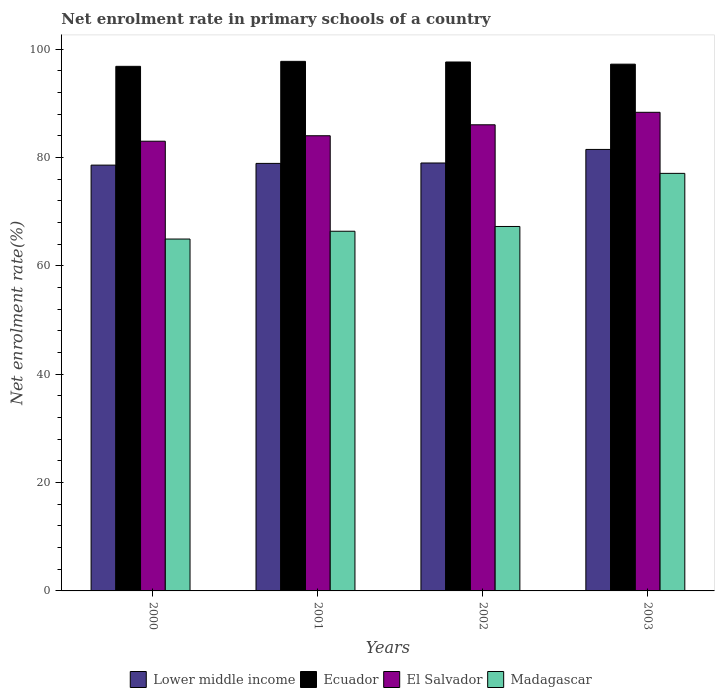How many groups of bars are there?
Your answer should be very brief. 4. Are the number of bars on each tick of the X-axis equal?
Ensure brevity in your answer.  Yes. How many bars are there on the 2nd tick from the left?
Offer a terse response. 4. How many bars are there on the 4th tick from the right?
Ensure brevity in your answer.  4. What is the label of the 1st group of bars from the left?
Offer a very short reply. 2000. What is the net enrolment rate in primary schools in El Salvador in 2003?
Offer a terse response. 88.34. Across all years, what is the maximum net enrolment rate in primary schools in El Salvador?
Keep it short and to the point. 88.34. Across all years, what is the minimum net enrolment rate in primary schools in El Salvador?
Provide a succinct answer. 83.01. What is the total net enrolment rate in primary schools in El Salvador in the graph?
Offer a terse response. 341.4. What is the difference between the net enrolment rate in primary schools in Lower middle income in 2000 and that in 2002?
Make the answer very short. -0.39. What is the difference between the net enrolment rate in primary schools in El Salvador in 2001 and the net enrolment rate in primary schools in Ecuador in 2002?
Give a very brief answer. -13.61. What is the average net enrolment rate in primary schools in Madagascar per year?
Provide a succinct answer. 68.92. In the year 2000, what is the difference between the net enrolment rate in primary schools in Lower middle income and net enrolment rate in primary schools in Ecuador?
Offer a very short reply. -18.23. In how many years, is the net enrolment rate in primary schools in Ecuador greater than 68 %?
Provide a succinct answer. 4. What is the ratio of the net enrolment rate in primary schools in Madagascar in 2000 to that in 2002?
Your answer should be compact. 0.97. Is the net enrolment rate in primary schools in Lower middle income in 2000 less than that in 2003?
Make the answer very short. Yes. What is the difference between the highest and the second highest net enrolment rate in primary schools in Madagascar?
Make the answer very short. 9.8. What is the difference between the highest and the lowest net enrolment rate in primary schools in El Salvador?
Ensure brevity in your answer.  5.34. Is the sum of the net enrolment rate in primary schools in Madagascar in 2002 and 2003 greater than the maximum net enrolment rate in primary schools in Lower middle income across all years?
Your answer should be compact. Yes. What does the 1st bar from the left in 2002 represents?
Offer a terse response. Lower middle income. What does the 2nd bar from the right in 2003 represents?
Your answer should be very brief. El Salvador. Is it the case that in every year, the sum of the net enrolment rate in primary schools in El Salvador and net enrolment rate in primary schools in Lower middle income is greater than the net enrolment rate in primary schools in Ecuador?
Your answer should be compact. Yes. How many bars are there?
Ensure brevity in your answer.  16. Are all the bars in the graph horizontal?
Provide a short and direct response. No. How many years are there in the graph?
Ensure brevity in your answer.  4. Are the values on the major ticks of Y-axis written in scientific E-notation?
Offer a terse response. No. Does the graph contain any zero values?
Provide a succinct answer. No. Does the graph contain grids?
Offer a very short reply. No. Where does the legend appear in the graph?
Give a very brief answer. Bottom center. How are the legend labels stacked?
Provide a succinct answer. Horizontal. What is the title of the graph?
Keep it short and to the point. Net enrolment rate in primary schools of a country. What is the label or title of the X-axis?
Make the answer very short. Years. What is the label or title of the Y-axis?
Your answer should be compact. Net enrolment rate(%). What is the Net enrolment rate(%) in Lower middle income in 2000?
Provide a short and direct response. 78.59. What is the Net enrolment rate(%) in Ecuador in 2000?
Make the answer very short. 96.83. What is the Net enrolment rate(%) in El Salvador in 2000?
Make the answer very short. 83.01. What is the Net enrolment rate(%) in Madagascar in 2000?
Ensure brevity in your answer.  64.95. What is the Net enrolment rate(%) in Lower middle income in 2001?
Keep it short and to the point. 78.91. What is the Net enrolment rate(%) of Ecuador in 2001?
Your answer should be very brief. 97.75. What is the Net enrolment rate(%) of El Salvador in 2001?
Keep it short and to the point. 84.02. What is the Net enrolment rate(%) in Madagascar in 2001?
Offer a terse response. 66.39. What is the Net enrolment rate(%) in Lower middle income in 2002?
Make the answer very short. 78.99. What is the Net enrolment rate(%) of Ecuador in 2002?
Offer a terse response. 97.63. What is the Net enrolment rate(%) in El Salvador in 2002?
Your answer should be very brief. 86.04. What is the Net enrolment rate(%) in Madagascar in 2002?
Offer a very short reply. 67.27. What is the Net enrolment rate(%) of Lower middle income in 2003?
Your answer should be compact. 81.49. What is the Net enrolment rate(%) in Ecuador in 2003?
Make the answer very short. 97.23. What is the Net enrolment rate(%) of El Salvador in 2003?
Your answer should be very brief. 88.34. What is the Net enrolment rate(%) of Madagascar in 2003?
Provide a succinct answer. 77.07. Across all years, what is the maximum Net enrolment rate(%) in Lower middle income?
Give a very brief answer. 81.49. Across all years, what is the maximum Net enrolment rate(%) in Ecuador?
Your answer should be compact. 97.75. Across all years, what is the maximum Net enrolment rate(%) of El Salvador?
Offer a terse response. 88.34. Across all years, what is the maximum Net enrolment rate(%) in Madagascar?
Your answer should be compact. 77.07. Across all years, what is the minimum Net enrolment rate(%) of Lower middle income?
Ensure brevity in your answer.  78.59. Across all years, what is the minimum Net enrolment rate(%) of Ecuador?
Provide a short and direct response. 96.83. Across all years, what is the minimum Net enrolment rate(%) in El Salvador?
Provide a short and direct response. 83.01. Across all years, what is the minimum Net enrolment rate(%) in Madagascar?
Your answer should be very brief. 64.95. What is the total Net enrolment rate(%) in Lower middle income in the graph?
Give a very brief answer. 317.98. What is the total Net enrolment rate(%) of Ecuador in the graph?
Keep it short and to the point. 389.43. What is the total Net enrolment rate(%) of El Salvador in the graph?
Give a very brief answer. 341.4. What is the total Net enrolment rate(%) of Madagascar in the graph?
Make the answer very short. 275.68. What is the difference between the Net enrolment rate(%) in Lower middle income in 2000 and that in 2001?
Keep it short and to the point. -0.32. What is the difference between the Net enrolment rate(%) of Ecuador in 2000 and that in 2001?
Your answer should be very brief. -0.92. What is the difference between the Net enrolment rate(%) in El Salvador in 2000 and that in 2001?
Give a very brief answer. -1.01. What is the difference between the Net enrolment rate(%) of Madagascar in 2000 and that in 2001?
Your answer should be very brief. -1.44. What is the difference between the Net enrolment rate(%) in Lower middle income in 2000 and that in 2002?
Provide a succinct answer. -0.39. What is the difference between the Net enrolment rate(%) in Ecuador in 2000 and that in 2002?
Keep it short and to the point. -0.8. What is the difference between the Net enrolment rate(%) of El Salvador in 2000 and that in 2002?
Offer a very short reply. -3.03. What is the difference between the Net enrolment rate(%) of Madagascar in 2000 and that in 2002?
Offer a very short reply. -2.32. What is the difference between the Net enrolment rate(%) in Lower middle income in 2000 and that in 2003?
Your response must be concise. -2.9. What is the difference between the Net enrolment rate(%) in Ecuador in 2000 and that in 2003?
Provide a short and direct response. -0.4. What is the difference between the Net enrolment rate(%) in El Salvador in 2000 and that in 2003?
Give a very brief answer. -5.34. What is the difference between the Net enrolment rate(%) in Madagascar in 2000 and that in 2003?
Provide a succinct answer. -12.12. What is the difference between the Net enrolment rate(%) in Lower middle income in 2001 and that in 2002?
Your answer should be very brief. -0.08. What is the difference between the Net enrolment rate(%) of Ecuador in 2001 and that in 2002?
Keep it short and to the point. 0.12. What is the difference between the Net enrolment rate(%) in El Salvador in 2001 and that in 2002?
Ensure brevity in your answer.  -2.02. What is the difference between the Net enrolment rate(%) of Madagascar in 2001 and that in 2002?
Offer a terse response. -0.88. What is the difference between the Net enrolment rate(%) of Lower middle income in 2001 and that in 2003?
Your answer should be very brief. -2.58. What is the difference between the Net enrolment rate(%) in Ecuador in 2001 and that in 2003?
Offer a terse response. 0.52. What is the difference between the Net enrolment rate(%) in El Salvador in 2001 and that in 2003?
Your answer should be compact. -4.33. What is the difference between the Net enrolment rate(%) of Madagascar in 2001 and that in 2003?
Your answer should be compact. -10.68. What is the difference between the Net enrolment rate(%) in Lower middle income in 2002 and that in 2003?
Your answer should be compact. -2.5. What is the difference between the Net enrolment rate(%) of Ecuador in 2002 and that in 2003?
Provide a short and direct response. 0.4. What is the difference between the Net enrolment rate(%) in El Salvador in 2002 and that in 2003?
Your answer should be very brief. -2.31. What is the difference between the Net enrolment rate(%) in Madagascar in 2002 and that in 2003?
Ensure brevity in your answer.  -9.8. What is the difference between the Net enrolment rate(%) of Lower middle income in 2000 and the Net enrolment rate(%) of Ecuador in 2001?
Give a very brief answer. -19.15. What is the difference between the Net enrolment rate(%) in Lower middle income in 2000 and the Net enrolment rate(%) in El Salvador in 2001?
Your answer should be compact. -5.42. What is the difference between the Net enrolment rate(%) of Lower middle income in 2000 and the Net enrolment rate(%) of Madagascar in 2001?
Ensure brevity in your answer.  12.21. What is the difference between the Net enrolment rate(%) of Ecuador in 2000 and the Net enrolment rate(%) of El Salvador in 2001?
Keep it short and to the point. 12.81. What is the difference between the Net enrolment rate(%) in Ecuador in 2000 and the Net enrolment rate(%) in Madagascar in 2001?
Keep it short and to the point. 30.44. What is the difference between the Net enrolment rate(%) in El Salvador in 2000 and the Net enrolment rate(%) in Madagascar in 2001?
Make the answer very short. 16.62. What is the difference between the Net enrolment rate(%) of Lower middle income in 2000 and the Net enrolment rate(%) of Ecuador in 2002?
Make the answer very short. -19.03. What is the difference between the Net enrolment rate(%) of Lower middle income in 2000 and the Net enrolment rate(%) of El Salvador in 2002?
Provide a succinct answer. -7.44. What is the difference between the Net enrolment rate(%) in Lower middle income in 2000 and the Net enrolment rate(%) in Madagascar in 2002?
Your answer should be very brief. 11.33. What is the difference between the Net enrolment rate(%) of Ecuador in 2000 and the Net enrolment rate(%) of El Salvador in 2002?
Provide a succinct answer. 10.79. What is the difference between the Net enrolment rate(%) of Ecuador in 2000 and the Net enrolment rate(%) of Madagascar in 2002?
Give a very brief answer. 29.56. What is the difference between the Net enrolment rate(%) of El Salvador in 2000 and the Net enrolment rate(%) of Madagascar in 2002?
Your answer should be compact. 15.74. What is the difference between the Net enrolment rate(%) in Lower middle income in 2000 and the Net enrolment rate(%) in Ecuador in 2003?
Give a very brief answer. -18.63. What is the difference between the Net enrolment rate(%) of Lower middle income in 2000 and the Net enrolment rate(%) of El Salvador in 2003?
Ensure brevity in your answer.  -9.75. What is the difference between the Net enrolment rate(%) in Lower middle income in 2000 and the Net enrolment rate(%) in Madagascar in 2003?
Provide a succinct answer. 1.52. What is the difference between the Net enrolment rate(%) in Ecuador in 2000 and the Net enrolment rate(%) in El Salvador in 2003?
Provide a short and direct response. 8.48. What is the difference between the Net enrolment rate(%) in Ecuador in 2000 and the Net enrolment rate(%) in Madagascar in 2003?
Ensure brevity in your answer.  19.76. What is the difference between the Net enrolment rate(%) in El Salvador in 2000 and the Net enrolment rate(%) in Madagascar in 2003?
Your response must be concise. 5.93. What is the difference between the Net enrolment rate(%) of Lower middle income in 2001 and the Net enrolment rate(%) of Ecuador in 2002?
Ensure brevity in your answer.  -18.72. What is the difference between the Net enrolment rate(%) in Lower middle income in 2001 and the Net enrolment rate(%) in El Salvador in 2002?
Keep it short and to the point. -7.13. What is the difference between the Net enrolment rate(%) in Lower middle income in 2001 and the Net enrolment rate(%) in Madagascar in 2002?
Make the answer very short. 11.64. What is the difference between the Net enrolment rate(%) in Ecuador in 2001 and the Net enrolment rate(%) in El Salvador in 2002?
Provide a short and direct response. 11.71. What is the difference between the Net enrolment rate(%) of Ecuador in 2001 and the Net enrolment rate(%) of Madagascar in 2002?
Keep it short and to the point. 30.48. What is the difference between the Net enrolment rate(%) in El Salvador in 2001 and the Net enrolment rate(%) in Madagascar in 2002?
Offer a very short reply. 16.75. What is the difference between the Net enrolment rate(%) in Lower middle income in 2001 and the Net enrolment rate(%) in Ecuador in 2003?
Provide a short and direct response. -18.32. What is the difference between the Net enrolment rate(%) of Lower middle income in 2001 and the Net enrolment rate(%) of El Salvador in 2003?
Your answer should be very brief. -9.43. What is the difference between the Net enrolment rate(%) of Lower middle income in 2001 and the Net enrolment rate(%) of Madagascar in 2003?
Offer a terse response. 1.84. What is the difference between the Net enrolment rate(%) of Ecuador in 2001 and the Net enrolment rate(%) of El Salvador in 2003?
Give a very brief answer. 9.4. What is the difference between the Net enrolment rate(%) in Ecuador in 2001 and the Net enrolment rate(%) in Madagascar in 2003?
Ensure brevity in your answer.  20.68. What is the difference between the Net enrolment rate(%) of El Salvador in 2001 and the Net enrolment rate(%) of Madagascar in 2003?
Ensure brevity in your answer.  6.94. What is the difference between the Net enrolment rate(%) of Lower middle income in 2002 and the Net enrolment rate(%) of Ecuador in 2003?
Provide a succinct answer. -18.24. What is the difference between the Net enrolment rate(%) in Lower middle income in 2002 and the Net enrolment rate(%) in El Salvador in 2003?
Ensure brevity in your answer.  -9.36. What is the difference between the Net enrolment rate(%) of Lower middle income in 2002 and the Net enrolment rate(%) of Madagascar in 2003?
Make the answer very short. 1.92. What is the difference between the Net enrolment rate(%) in Ecuador in 2002 and the Net enrolment rate(%) in El Salvador in 2003?
Offer a very short reply. 9.29. What is the difference between the Net enrolment rate(%) in Ecuador in 2002 and the Net enrolment rate(%) in Madagascar in 2003?
Offer a terse response. 20.56. What is the difference between the Net enrolment rate(%) of El Salvador in 2002 and the Net enrolment rate(%) of Madagascar in 2003?
Provide a succinct answer. 8.97. What is the average Net enrolment rate(%) of Lower middle income per year?
Your answer should be compact. 79.5. What is the average Net enrolment rate(%) of Ecuador per year?
Your response must be concise. 97.36. What is the average Net enrolment rate(%) of El Salvador per year?
Offer a very short reply. 85.35. What is the average Net enrolment rate(%) in Madagascar per year?
Provide a succinct answer. 68.92. In the year 2000, what is the difference between the Net enrolment rate(%) in Lower middle income and Net enrolment rate(%) in Ecuador?
Provide a succinct answer. -18.23. In the year 2000, what is the difference between the Net enrolment rate(%) in Lower middle income and Net enrolment rate(%) in El Salvador?
Provide a succinct answer. -4.41. In the year 2000, what is the difference between the Net enrolment rate(%) in Lower middle income and Net enrolment rate(%) in Madagascar?
Provide a succinct answer. 13.64. In the year 2000, what is the difference between the Net enrolment rate(%) in Ecuador and Net enrolment rate(%) in El Salvador?
Your answer should be very brief. 13.82. In the year 2000, what is the difference between the Net enrolment rate(%) in Ecuador and Net enrolment rate(%) in Madagascar?
Provide a short and direct response. 31.88. In the year 2000, what is the difference between the Net enrolment rate(%) of El Salvador and Net enrolment rate(%) of Madagascar?
Your answer should be compact. 18.06. In the year 2001, what is the difference between the Net enrolment rate(%) of Lower middle income and Net enrolment rate(%) of Ecuador?
Make the answer very short. -18.84. In the year 2001, what is the difference between the Net enrolment rate(%) of Lower middle income and Net enrolment rate(%) of El Salvador?
Your response must be concise. -5.11. In the year 2001, what is the difference between the Net enrolment rate(%) of Lower middle income and Net enrolment rate(%) of Madagascar?
Ensure brevity in your answer.  12.52. In the year 2001, what is the difference between the Net enrolment rate(%) of Ecuador and Net enrolment rate(%) of El Salvador?
Your answer should be compact. 13.73. In the year 2001, what is the difference between the Net enrolment rate(%) in Ecuador and Net enrolment rate(%) in Madagascar?
Your answer should be compact. 31.36. In the year 2001, what is the difference between the Net enrolment rate(%) of El Salvador and Net enrolment rate(%) of Madagascar?
Your response must be concise. 17.63. In the year 2002, what is the difference between the Net enrolment rate(%) in Lower middle income and Net enrolment rate(%) in Ecuador?
Provide a short and direct response. -18.64. In the year 2002, what is the difference between the Net enrolment rate(%) of Lower middle income and Net enrolment rate(%) of El Salvador?
Make the answer very short. -7.05. In the year 2002, what is the difference between the Net enrolment rate(%) of Lower middle income and Net enrolment rate(%) of Madagascar?
Keep it short and to the point. 11.72. In the year 2002, what is the difference between the Net enrolment rate(%) in Ecuador and Net enrolment rate(%) in El Salvador?
Your answer should be very brief. 11.59. In the year 2002, what is the difference between the Net enrolment rate(%) in Ecuador and Net enrolment rate(%) in Madagascar?
Provide a succinct answer. 30.36. In the year 2002, what is the difference between the Net enrolment rate(%) of El Salvador and Net enrolment rate(%) of Madagascar?
Ensure brevity in your answer.  18.77. In the year 2003, what is the difference between the Net enrolment rate(%) in Lower middle income and Net enrolment rate(%) in Ecuador?
Give a very brief answer. -15.74. In the year 2003, what is the difference between the Net enrolment rate(%) in Lower middle income and Net enrolment rate(%) in El Salvador?
Ensure brevity in your answer.  -6.85. In the year 2003, what is the difference between the Net enrolment rate(%) in Lower middle income and Net enrolment rate(%) in Madagascar?
Make the answer very short. 4.42. In the year 2003, what is the difference between the Net enrolment rate(%) of Ecuador and Net enrolment rate(%) of El Salvador?
Your response must be concise. 8.89. In the year 2003, what is the difference between the Net enrolment rate(%) of Ecuador and Net enrolment rate(%) of Madagascar?
Give a very brief answer. 20.16. In the year 2003, what is the difference between the Net enrolment rate(%) in El Salvador and Net enrolment rate(%) in Madagascar?
Make the answer very short. 11.27. What is the ratio of the Net enrolment rate(%) of Lower middle income in 2000 to that in 2001?
Your answer should be very brief. 1. What is the ratio of the Net enrolment rate(%) in Ecuador in 2000 to that in 2001?
Your response must be concise. 0.99. What is the ratio of the Net enrolment rate(%) of El Salvador in 2000 to that in 2001?
Your response must be concise. 0.99. What is the ratio of the Net enrolment rate(%) in Madagascar in 2000 to that in 2001?
Give a very brief answer. 0.98. What is the ratio of the Net enrolment rate(%) in Lower middle income in 2000 to that in 2002?
Provide a short and direct response. 0.99. What is the ratio of the Net enrolment rate(%) of El Salvador in 2000 to that in 2002?
Give a very brief answer. 0.96. What is the ratio of the Net enrolment rate(%) of Madagascar in 2000 to that in 2002?
Provide a succinct answer. 0.97. What is the ratio of the Net enrolment rate(%) in Lower middle income in 2000 to that in 2003?
Make the answer very short. 0.96. What is the ratio of the Net enrolment rate(%) in El Salvador in 2000 to that in 2003?
Give a very brief answer. 0.94. What is the ratio of the Net enrolment rate(%) in Madagascar in 2000 to that in 2003?
Your response must be concise. 0.84. What is the ratio of the Net enrolment rate(%) in Lower middle income in 2001 to that in 2002?
Give a very brief answer. 1. What is the ratio of the Net enrolment rate(%) of El Salvador in 2001 to that in 2002?
Your response must be concise. 0.98. What is the ratio of the Net enrolment rate(%) in Madagascar in 2001 to that in 2002?
Make the answer very short. 0.99. What is the ratio of the Net enrolment rate(%) in Lower middle income in 2001 to that in 2003?
Provide a short and direct response. 0.97. What is the ratio of the Net enrolment rate(%) in El Salvador in 2001 to that in 2003?
Provide a succinct answer. 0.95. What is the ratio of the Net enrolment rate(%) in Madagascar in 2001 to that in 2003?
Give a very brief answer. 0.86. What is the ratio of the Net enrolment rate(%) of Lower middle income in 2002 to that in 2003?
Keep it short and to the point. 0.97. What is the ratio of the Net enrolment rate(%) of El Salvador in 2002 to that in 2003?
Provide a short and direct response. 0.97. What is the ratio of the Net enrolment rate(%) of Madagascar in 2002 to that in 2003?
Your response must be concise. 0.87. What is the difference between the highest and the second highest Net enrolment rate(%) of Lower middle income?
Ensure brevity in your answer.  2.5. What is the difference between the highest and the second highest Net enrolment rate(%) of Ecuador?
Your answer should be very brief. 0.12. What is the difference between the highest and the second highest Net enrolment rate(%) of El Salvador?
Offer a terse response. 2.31. What is the difference between the highest and the second highest Net enrolment rate(%) in Madagascar?
Your response must be concise. 9.8. What is the difference between the highest and the lowest Net enrolment rate(%) in Lower middle income?
Provide a short and direct response. 2.9. What is the difference between the highest and the lowest Net enrolment rate(%) of Ecuador?
Keep it short and to the point. 0.92. What is the difference between the highest and the lowest Net enrolment rate(%) of El Salvador?
Keep it short and to the point. 5.34. What is the difference between the highest and the lowest Net enrolment rate(%) in Madagascar?
Offer a very short reply. 12.12. 